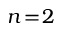Convert formula to latex. <formula><loc_0><loc_0><loc_500><loc_500>n \, = \, 2</formula> 